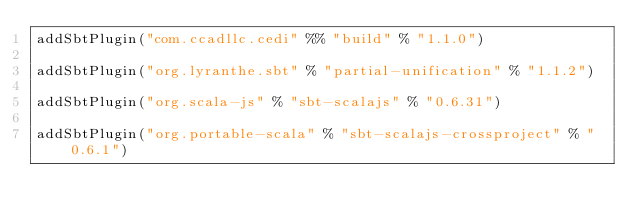<code> <loc_0><loc_0><loc_500><loc_500><_Scala_>addSbtPlugin("com.ccadllc.cedi" %% "build" % "1.1.0")

addSbtPlugin("org.lyranthe.sbt" % "partial-unification" % "1.1.2")

addSbtPlugin("org.scala-js" % "sbt-scalajs" % "0.6.31")

addSbtPlugin("org.portable-scala" % "sbt-scalajs-crossproject" % "0.6.1")
</code> 